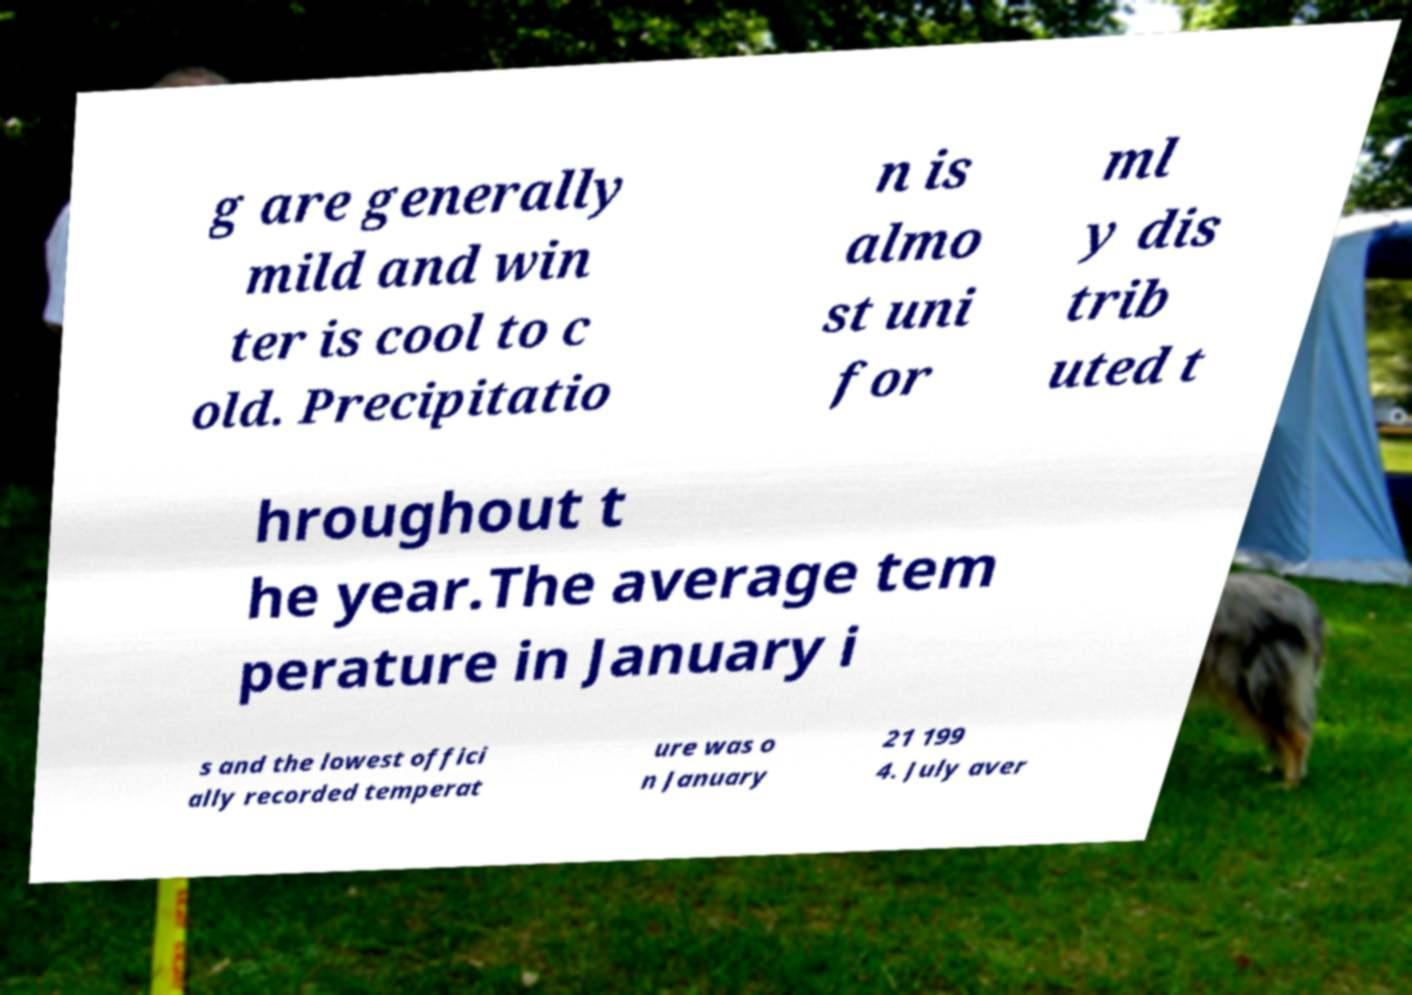I need the written content from this picture converted into text. Can you do that? g are generally mild and win ter is cool to c old. Precipitatio n is almo st uni for ml y dis trib uted t hroughout t he year.The average tem perature in January i s and the lowest offici ally recorded temperat ure was o n January 21 199 4. July aver 